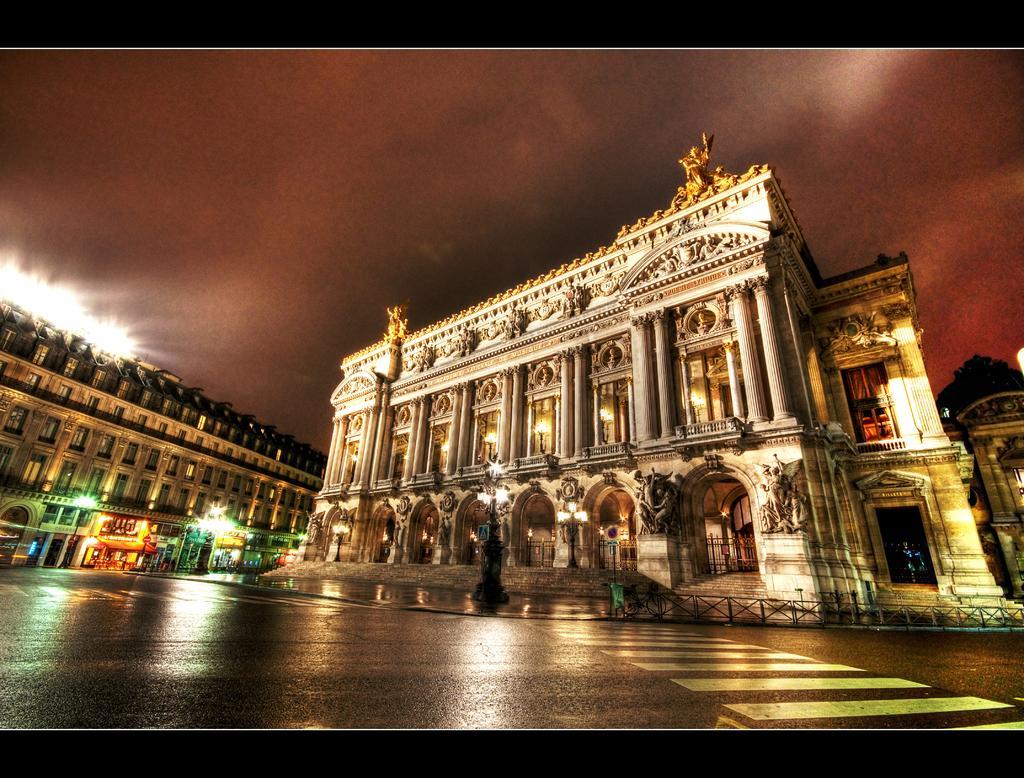Can you describe this image briefly? In this picture we can see buildings, lights, statues, sky and road. At the top and bottom of the image it is dark. 